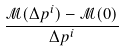Convert formula to latex. <formula><loc_0><loc_0><loc_500><loc_500>\frac { \mathcal { M } ( \Delta p ^ { i } ) - \mathcal { M } ( 0 ) } { \Delta p ^ { i } }</formula> 